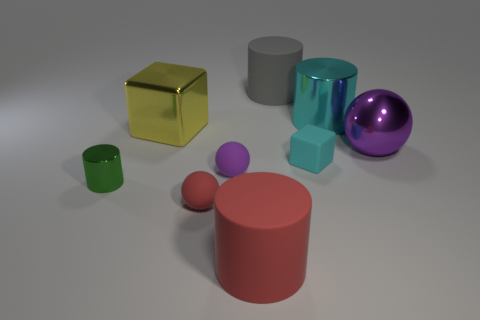Add 1 red matte cylinders. How many objects exist? 10 Subtract all gray matte cylinders. How many cylinders are left? 3 Subtract all yellow cylinders. How many purple balls are left? 2 Subtract all green cylinders. How many cylinders are left? 3 Subtract all blocks. How many objects are left? 7 Subtract all large red things. Subtract all cubes. How many objects are left? 6 Add 2 large purple spheres. How many large purple spheres are left? 3 Add 2 large gray cylinders. How many large gray cylinders exist? 3 Subtract 1 red cylinders. How many objects are left? 8 Subtract all cyan spheres. Subtract all yellow cubes. How many spheres are left? 3 